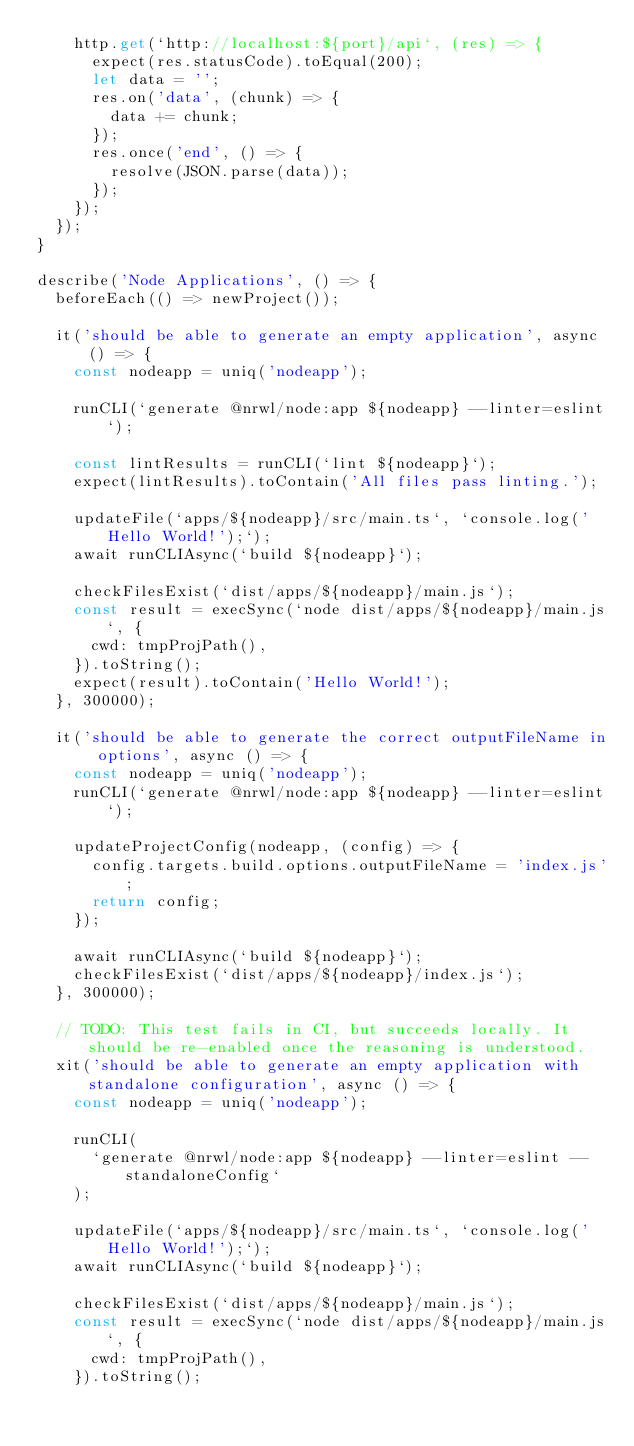Convert code to text. <code><loc_0><loc_0><loc_500><loc_500><_TypeScript_>    http.get(`http://localhost:${port}/api`, (res) => {
      expect(res.statusCode).toEqual(200);
      let data = '';
      res.on('data', (chunk) => {
        data += chunk;
      });
      res.once('end', () => {
        resolve(JSON.parse(data));
      });
    });
  });
}

describe('Node Applications', () => {
  beforeEach(() => newProject());

  it('should be able to generate an empty application', async () => {
    const nodeapp = uniq('nodeapp');

    runCLI(`generate @nrwl/node:app ${nodeapp} --linter=eslint`);

    const lintResults = runCLI(`lint ${nodeapp}`);
    expect(lintResults).toContain('All files pass linting.');

    updateFile(`apps/${nodeapp}/src/main.ts`, `console.log('Hello World!');`);
    await runCLIAsync(`build ${nodeapp}`);

    checkFilesExist(`dist/apps/${nodeapp}/main.js`);
    const result = execSync(`node dist/apps/${nodeapp}/main.js`, {
      cwd: tmpProjPath(),
    }).toString();
    expect(result).toContain('Hello World!');
  }, 300000);

  it('should be able to generate the correct outputFileName in options', async () => {
    const nodeapp = uniq('nodeapp');
    runCLI(`generate @nrwl/node:app ${nodeapp} --linter=eslint`);

    updateProjectConfig(nodeapp, (config) => {
      config.targets.build.options.outputFileName = 'index.js';
      return config;
    });

    await runCLIAsync(`build ${nodeapp}`);
    checkFilesExist(`dist/apps/${nodeapp}/index.js`);
  }, 300000);

  // TODO: This test fails in CI, but succeeds locally. It should be re-enabled once the reasoning is understood.
  xit('should be able to generate an empty application with standalone configuration', async () => {
    const nodeapp = uniq('nodeapp');

    runCLI(
      `generate @nrwl/node:app ${nodeapp} --linter=eslint --standaloneConfig`
    );

    updateFile(`apps/${nodeapp}/src/main.ts`, `console.log('Hello World!');`);
    await runCLIAsync(`build ${nodeapp}`);

    checkFilesExist(`dist/apps/${nodeapp}/main.js`);
    const result = execSync(`node dist/apps/${nodeapp}/main.js`, {
      cwd: tmpProjPath(),
    }).toString();</code> 